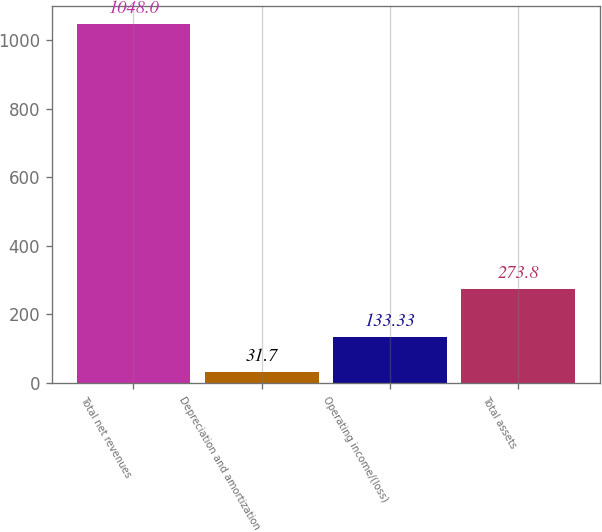Convert chart to OTSL. <chart><loc_0><loc_0><loc_500><loc_500><bar_chart><fcel>Total net revenues<fcel>Depreciation and amortization<fcel>Operating income/(loss)<fcel>Total assets<nl><fcel>1048<fcel>31.7<fcel>133.33<fcel>273.8<nl></chart> 